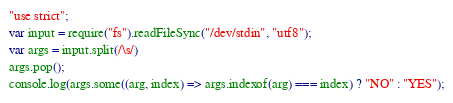Convert code to text. <code><loc_0><loc_0><loc_500><loc_500><_TypeScript_>"use strict";
var input = require("fs").readFileSync("/dev/stdin", "utf8");
var args = input.split(/\s/)
args.pop();
console.log(args.some((arg, index) => args.indexof(arg) === index) ? "NO" : "YES");</code> 